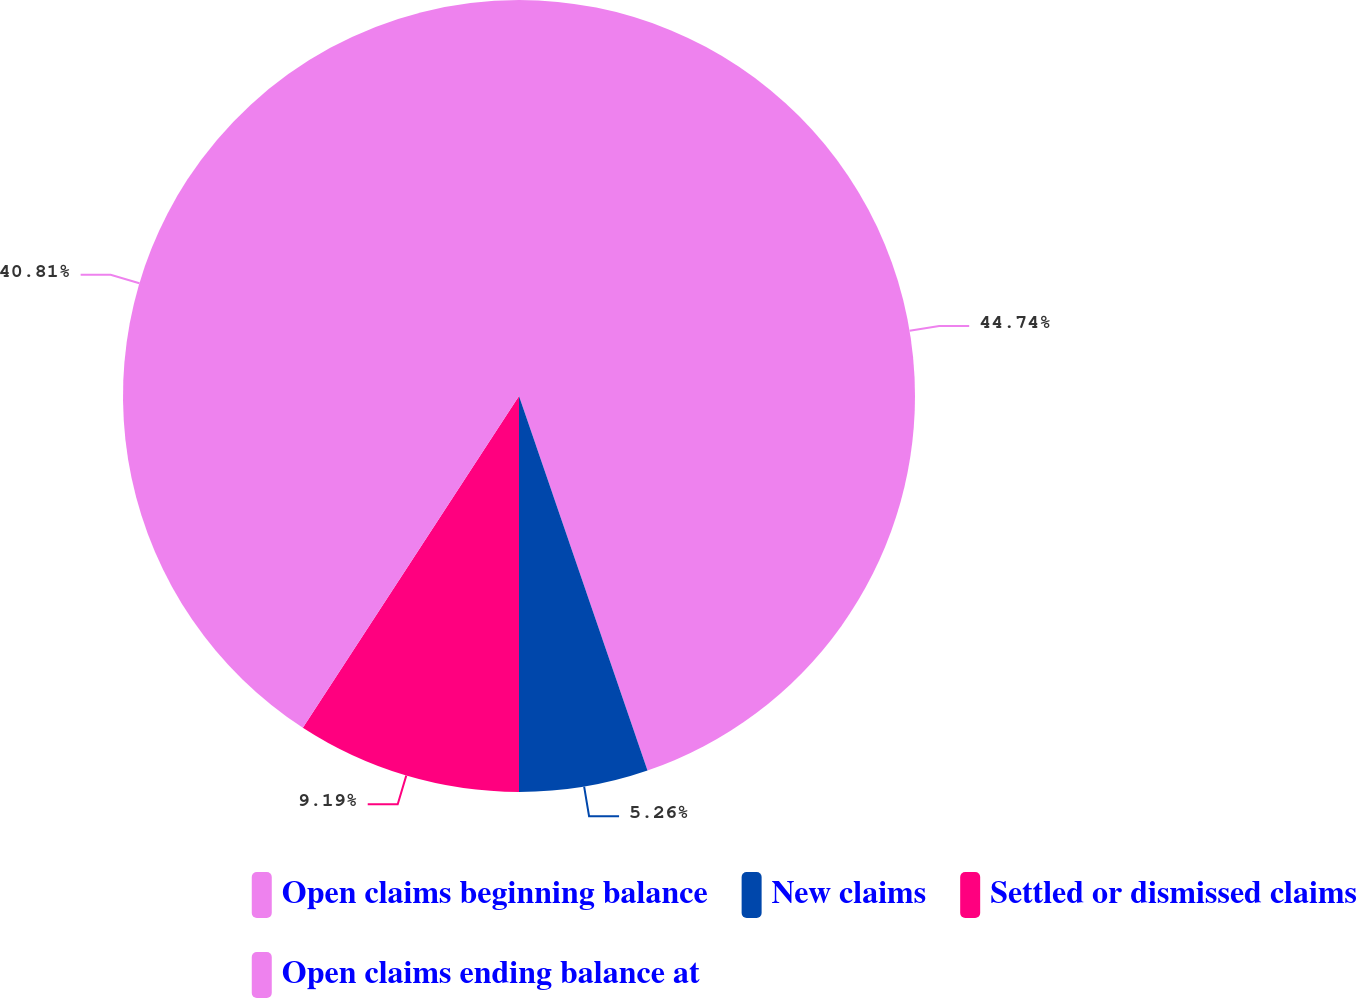Convert chart. <chart><loc_0><loc_0><loc_500><loc_500><pie_chart><fcel>Open claims beginning balance<fcel>New claims<fcel>Settled or dismissed claims<fcel>Open claims ending balance at<nl><fcel>44.74%<fcel>5.26%<fcel>9.19%<fcel>40.81%<nl></chart> 